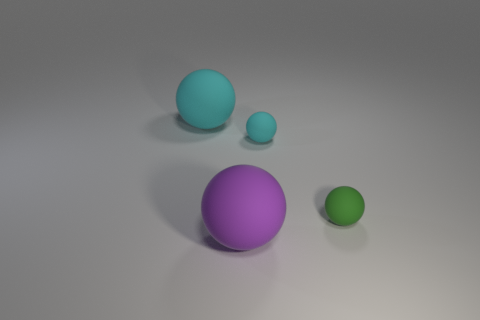Subtract all large purple rubber balls. How many balls are left? 3 Add 2 gray cylinders. How many objects exist? 6 Subtract all green balls. How many balls are left? 3 Subtract 4 balls. How many balls are left? 0 Subtract all cyan cylinders. How many brown balls are left? 0 Subtract all large purple rubber objects. Subtract all large blue rubber cylinders. How many objects are left? 3 Add 2 tiny green things. How many tiny green things are left? 3 Add 2 small brown matte spheres. How many small brown matte spheres exist? 2 Subtract 1 green spheres. How many objects are left? 3 Subtract all purple balls. Subtract all gray blocks. How many balls are left? 3 